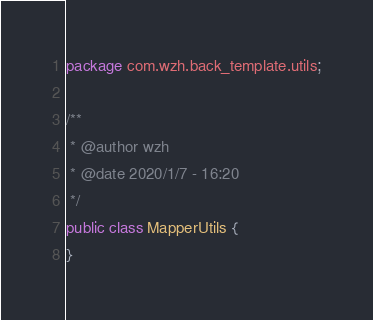<code> <loc_0><loc_0><loc_500><loc_500><_Java_>package com.wzh.back_template.utils;

/**
 * @author wzh
 * @date 2020/1/7 - 16:20
 */
public class MapperUtils {
}
</code> 